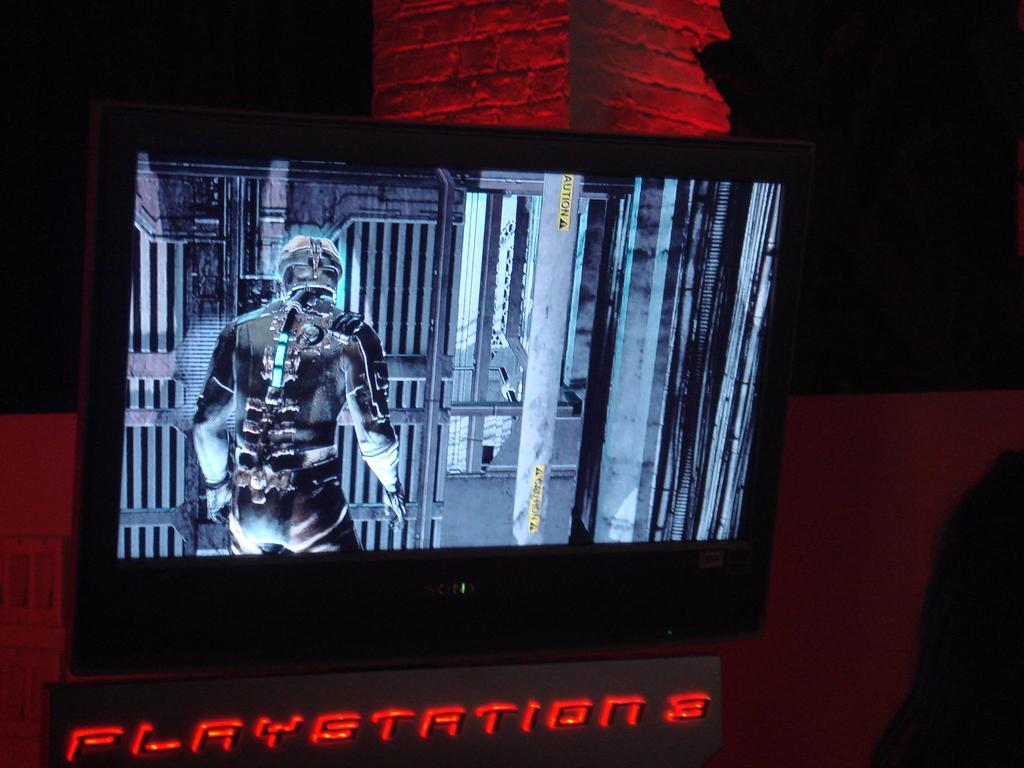<image>
Summarize the visual content of the image. Screen with the words Playstation 3 right under it. 